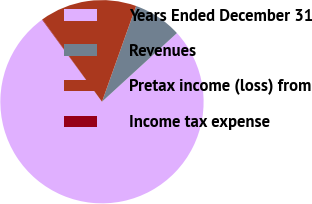<chart> <loc_0><loc_0><loc_500><loc_500><pie_chart><fcel>Years Ended December 31<fcel>Revenues<fcel>Pretax income (loss) from<fcel>Income tax expense<nl><fcel>76.76%<fcel>7.75%<fcel>15.41%<fcel>0.08%<nl></chart> 